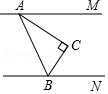What kind of mathematical principles can be observed in this geometric configuration? The geometric configuration in the image illustrates principles of parallel lines and transversal angles. It features the concepts of corresponding angles, where angles in matching corners when a line crosses two others are equal if the lines are parallel. It also uses basic concepts of angle measurement in triangles, specifically in right-angled triangles, demonstrating how different angle values can be determined through subtraction from 90 degrees. 